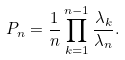Convert formula to latex. <formula><loc_0><loc_0><loc_500><loc_500>P _ { n } = \frac { 1 } { n } \prod _ { k = 1 } ^ { n - 1 } \frac { \lambda _ { k } } { \lambda _ { n } } .</formula> 